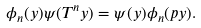Convert formula to latex. <formula><loc_0><loc_0><loc_500><loc_500>\phi _ { n } ( y ) \psi ( T ^ { n } y ) = \psi ( y ) \phi _ { n } ( p y ) .</formula> 